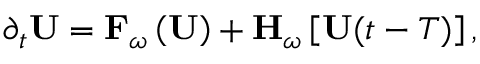<formula> <loc_0><loc_0><loc_500><loc_500>\partial _ { t } U = F _ { \omega } \left ( U \right ) + H _ { \omega } \left [ U { ( t - T ) } \right ] ,</formula> 